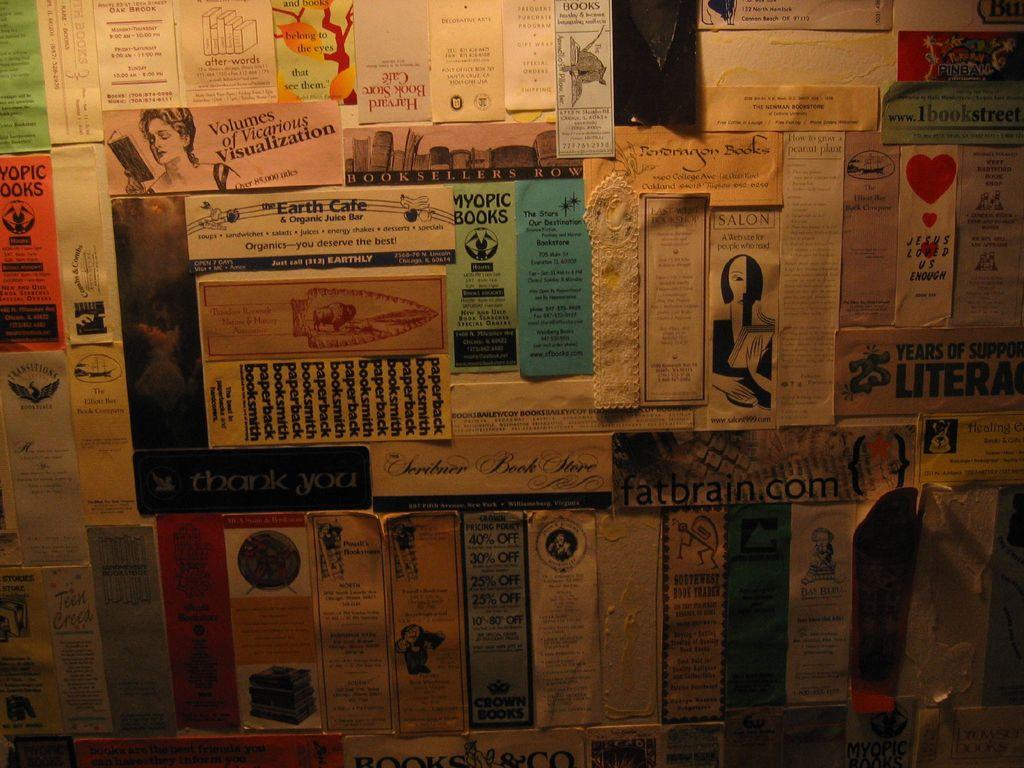What website is near the middle right?
Provide a short and direct response. Fatbrain.com. These are books right?
Provide a succinct answer. No. 